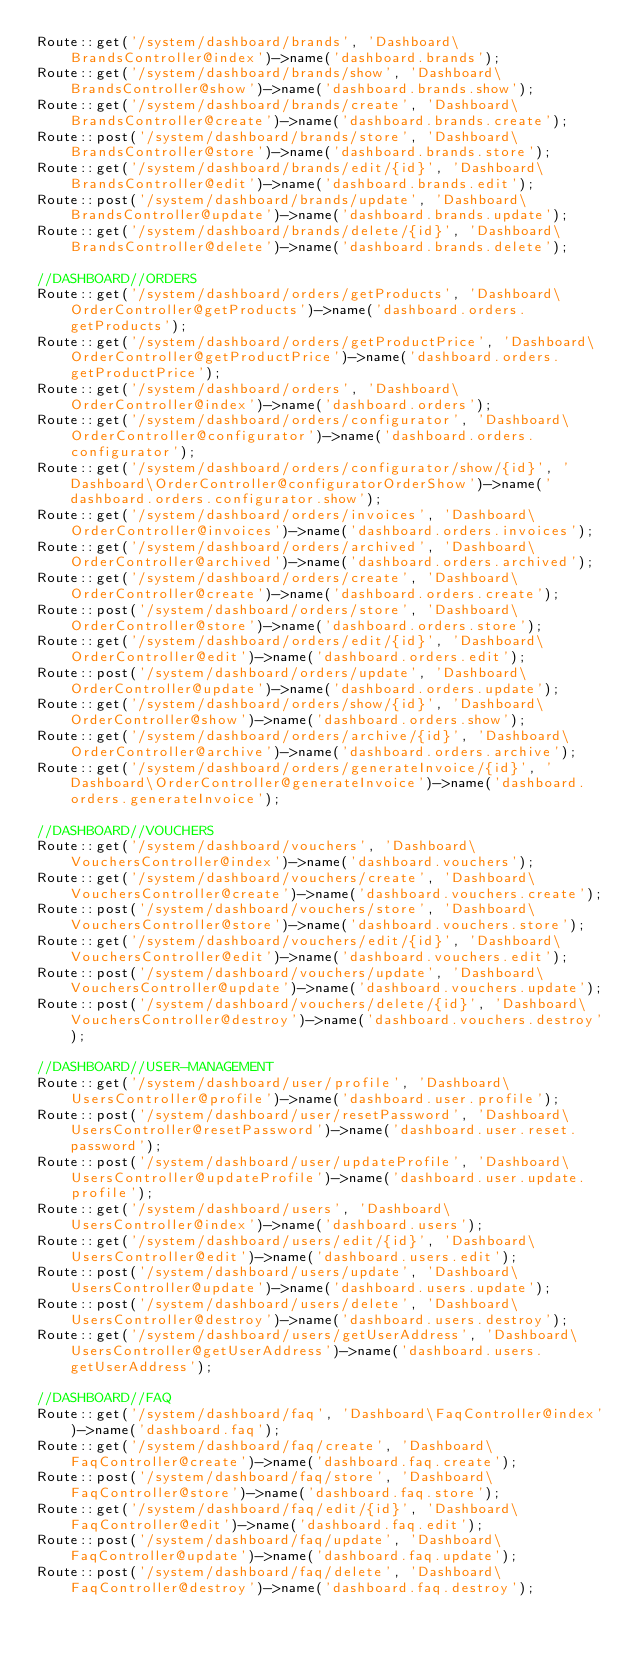Convert code to text. <code><loc_0><loc_0><loc_500><loc_500><_PHP_>Route::get('/system/dashboard/brands', 'Dashboard\BrandsController@index')->name('dashboard.brands');
Route::get('/system/dashboard/brands/show', 'Dashboard\BrandsController@show')->name('dashboard.brands.show');
Route::get('/system/dashboard/brands/create', 'Dashboard\BrandsController@create')->name('dashboard.brands.create');
Route::post('/system/dashboard/brands/store', 'Dashboard\BrandsController@store')->name('dashboard.brands.store');
Route::get('/system/dashboard/brands/edit/{id}', 'Dashboard\BrandsController@edit')->name('dashboard.brands.edit');
Route::post('/system/dashboard/brands/update', 'Dashboard\BrandsController@update')->name('dashboard.brands.update');
Route::get('/system/dashboard/brands/delete/{id}', 'Dashboard\BrandsController@delete')->name('dashboard.brands.delete');

//DASHBOARD//ORDERS
Route::get('/system/dashboard/orders/getProducts', 'Dashboard\OrderController@getProducts')->name('dashboard.orders.getProducts');
Route::get('/system/dashboard/orders/getProductPrice', 'Dashboard\OrderController@getProductPrice')->name('dashboard.orders.getProductPrice');
Route::get('/system/dashboard/orders', 'Dashboard\OrderController@index')->name('dashboard.orders');
Route::get('/system/dashboard/orders/configurator', 'Dashboard\OrderController@configurator')->name('dashboard.orders.configurator');
Route::get('/system/dashboard/orders/configurator/show/{id}', 'Dashboard\OrderController@configuratorOrderShow')->name('dashboard.orders.configurator.show');
Route::get('/system/dashboard/orders/invoices', 'Dashboard\OrderController@invoices')->name('dashboard.orders.invoices');
Route::get('/system/dashboard/orders/archived', 'Dashboard\OrderController@archived')->name('dashboard.orders.archived');
Route::get('/system/dashboard/orders/create', 'Dashboard\OrderController@create')->name('dashboard.orders.create');
Route::post('/system/dashboard/orders/store', 'Dashboard\OrderController@store')->name('dashboard.orders.store');
Route::get('/system/dashboard/orders/edit/{id}', 'Dashboard\OrderController@edit')->name('dashboard.orders.edit');
Route::post('/system/dashboard/orders/update', 'Dashboard\OrderController@update')->name('dashboard.orders.update');
Route::get('/system/dashboard/orders/show/{id}', 'Dashboard\OrderController@show')->name('dashboard.orders.show');
Route::get('/system/dashboard/orders/archive/{id}', 'Dashboard\OrderController@archive')->name('dashboard.orders.archive');
Route::get('/system/dashboard/orders/generateInvoice/{id}', 'Dashboard\OrderController@generateInvoice')->name('dashboard.orders.generateInvoice');

//DASHBOARD//VOUCHERS
Route::get('/system/dashboard/vouchers', 'Dashboard\VouchersController@index')->name('dashboard.vouchers');
Route::get('/system/dashboard/vouchers/create', 'Dashboard\VouchersController@create')->name('dashboard.vouchers.create');
Route::post('/system/dashboard/vouchers/store', 'Dashboard\VouchersController@store')->name('dashboard.vouchers.store');
Route::get('/system/dashboard/vouchers/edit/{id}', 'Dashboard\VouchersController@edit')->name('dashboard.vouchers.edit');
Route::post('/system/dashboard/vouchers/update', 'Dashboard\VouchersController@update')->name('dashboard.vouchers.update');
Route::post('/system/dashboard/vouchers/delete/{id}', 'Dashboard\VouchersController@destroy')->name('dashboard.vouchers.destroy');

//DASHBOARD//USER-MANAGEMENT
Route::get('/system/dashboard/user/profile', 'Dashboard\UsersController@profile')->name('dashboard.user.profile');
Route::post('/system/dashboard/user/resetPassword', 'Dashboard\UsersController@resetPassword')->name('dashboard.user.reset.password');
Route::post('/system/dashboard/user/updateProfile', 'Dashboard\UsersController@updateProfile')->name('dashboard.user.update.profile');
Route::get('/system/dashboard/users', 'Dashboard\UsersController@index')->name('dashboard.users');
Route::get('/system/dashboard/users/edit/{id}', 'Dashboard\UsersController@edit')->name('dashboard.users.edit');
Route::post('/system/dashboard/users/update', 'Dashboard\UsersController@update')->name('dashboard.users.update');
Route::post('/system/dashboard/users/delete', 'Dashboard\UsersController@destroy')->name('dashboard.users.destroy');
Route::get('/system/dashboard/users/getUserAddress', 'Dashboard\UsersController@getUserAddress')->name('dashboard.users.getUserAddress');

//DASHBOARD//FAQ
Route::get('/system/dashboard/faq', 'Dashboard\FaqController@index')->name('dashboard.faq');
Route::get('/system/dashboard/faq/create', 'Dashboard\FaqController@create')->name('dashboard.faq.create');
Route::post('/system/dashboard/faq/store', 'Dashboard\FaqController@store')->name('dashboard.faq.store');
Route::get('/system/dashboard/faq/edit/{id}', 'Dashboard\FaqController@edit')->name('dashboard.faq.edit');
Route::post('/system/dashboard/faq/update', 'Dashboard\FaqController@update')->name('dashboard.faq.update');
Route::post('/system/dashboard/faq/delete', 'Dashboard\FaqController@destroy')->name('dashboard.faq.destroy');
</code> 